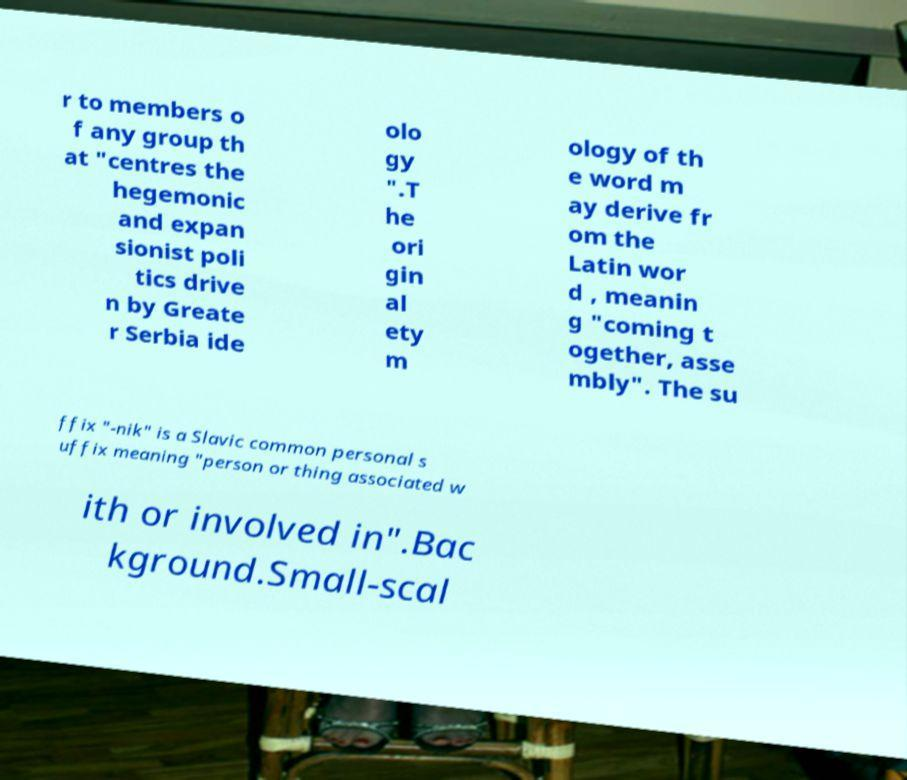Can you read and provide the text displayed in the image?This photo seems to have some interesting text. Can you extract and type it out for me? r to members o f any group th at "centres the hegemonic and expan sionist poli tics drive n by Greate r Serbia ide olo gy ".T he ori gin al ety m ology of th e word m ay derive fr om the Latin wor d , meanin g "coming t ogether, asse mbly". The su ffix "-nik" is a Slavic common personal s uffix meaning "person or thing associated w ith or involved in".Bac kground.Small-scal 